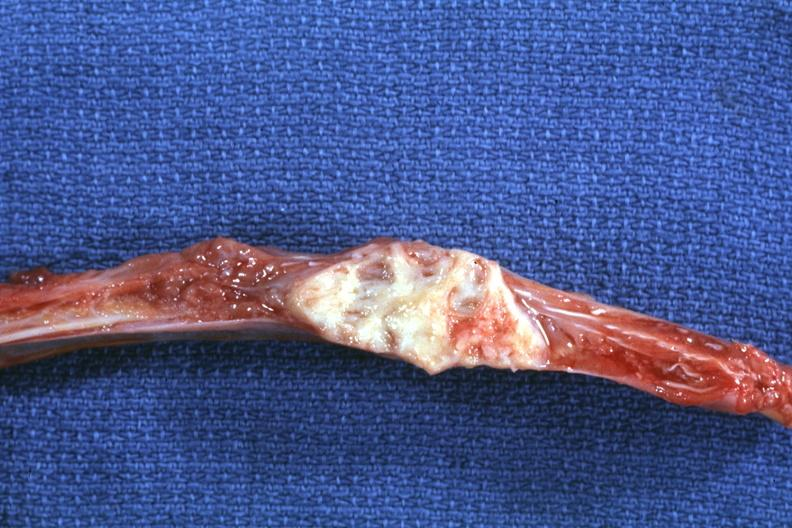how does this image show rib?
Answer the question using a single word or phrase. With well shown lesion 